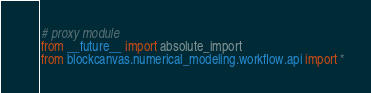Convert code to text. <code><loc_0><loc_0><loc_500><loc_500><_Python_># proxy module
from __future__ import absolute_import
from blockcanvas.numerical_modeling.workflow.api import *
</code> 